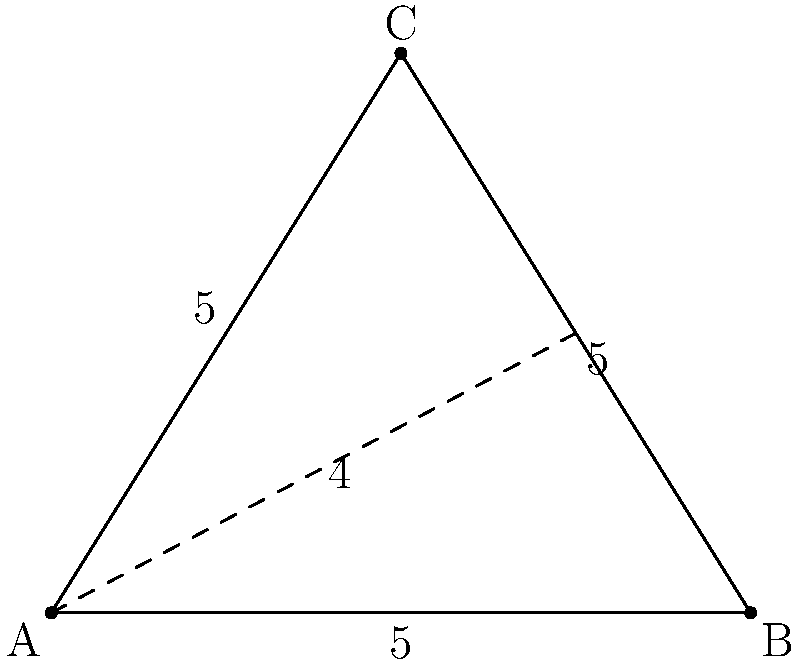A triangular field ABC is equilateral with side length 10 units. The tractor needs to cover the entire field starting from point A. What is the most efficient path for the tractor to follow, and what is the total distance traveled? To find the most efficient path for the tractor, we need to consider the following steps:

1) In an equilateral triangle, the most efficient path is to go from one vertex to the midpoint of the opposite side, then to the other two vertices.

2) Let's call the midpoint of BC as M.

3) The path will be: A → M → B → C → A

4) To calculate the total distance:
   
   a) Distance AM (height of the triangle):
      $h = \frac{\sqrt{3}}{2} \times 10 = 5\sqrt{3}$ units
   
   b) Distance MB = MC = 5 units (half of the side length)
   
   c) Distances AB = BC = CA = 10 units

5) Total distance = AM + MB + BC + CA
                  = $5\sqrt{3} + 5 + 10 + 10$
                  = $5\sqrt{3} + 25$ units

Therefore, the most efficient path is A → M → B → C → A, and the total distance traveled is $5\sqrt{3} + 25$ units.
Answer: A → M → B → C → A; $5\sqrt{3} + 25$ units 